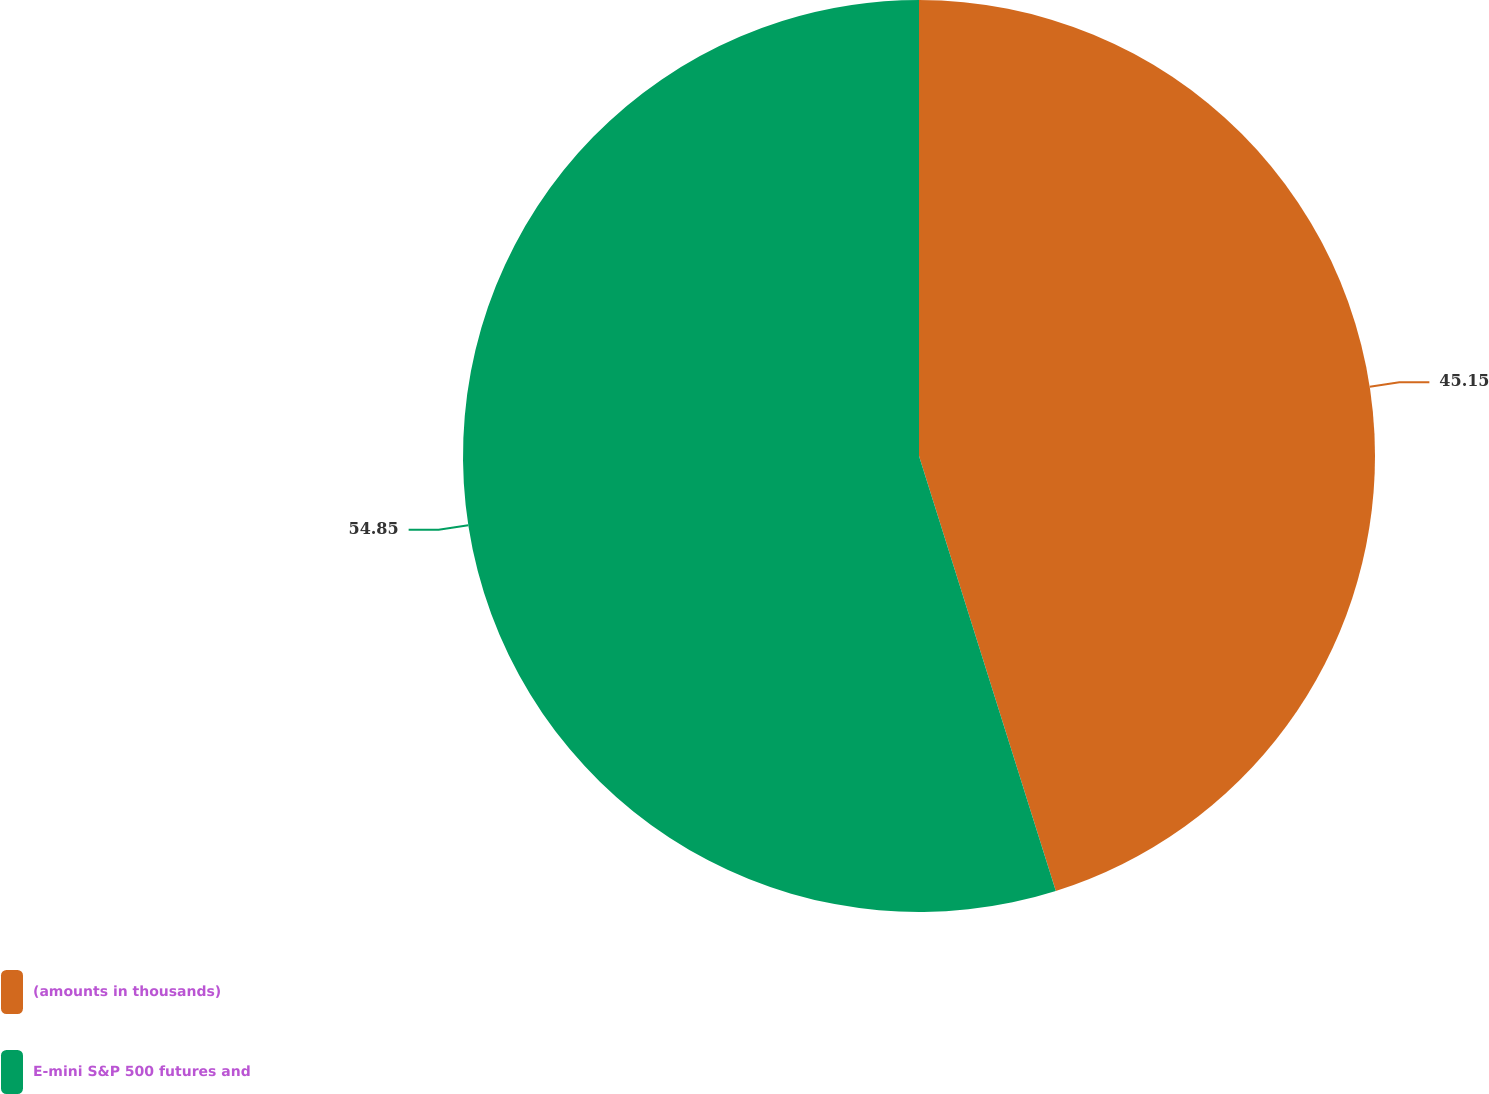Convert chart. <chart><loc_0><loc_0><loc_500><loc_500><pie_chart><fcel>(amounts in thousands)<fcel>E-mini S&P 500 futures and<nl><fcel>45.15%<fcel>54.85%<nl></chart> 